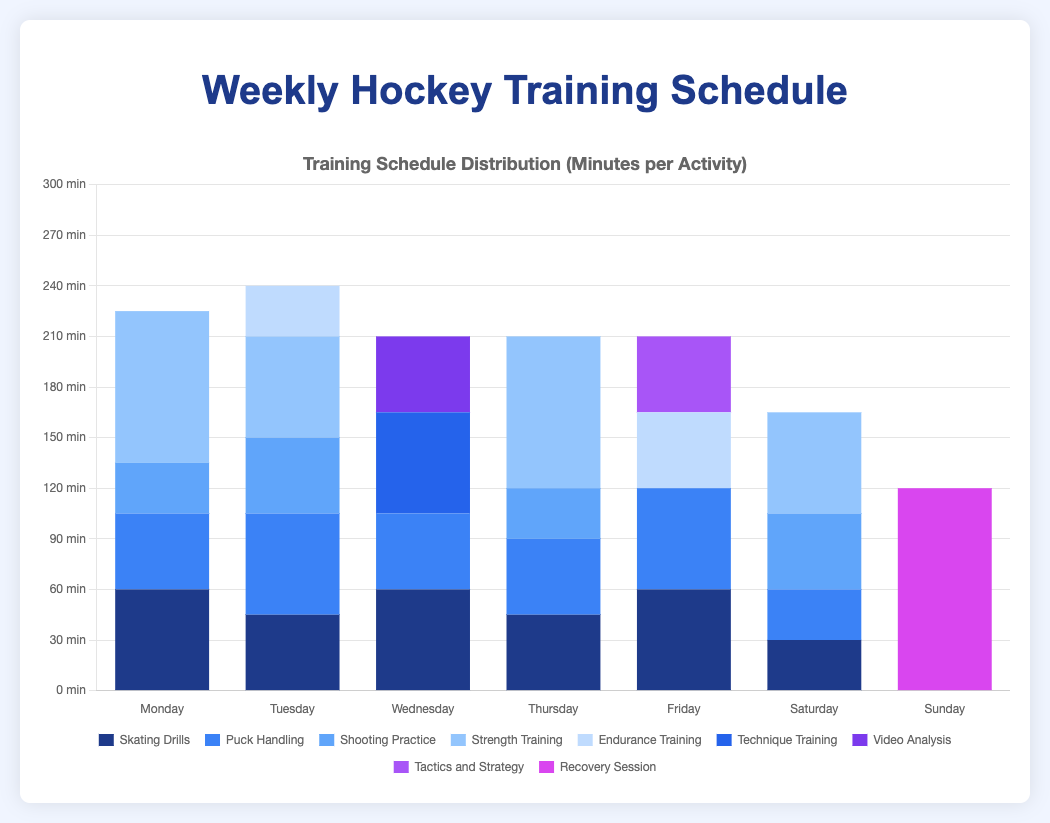What is the total duration of Skating Drills throughout the week? To find the total duration of Skating Drills, sum the duration for each day: 60 (Monday) + 45 (Tuesday) + 60 (Wednesday) + 45 (Thursday) + 60 (Friday) + 30 (Saturday) = 300 minutes.
Answer: 300 minutes On which day is Puck Handling practiced the most, and how long is it practiced? Compare the duration of Puck Handling on each day it appears: 45 (Monday), 60 (Tuesday), 45 (Wednesday), 45 (Thursday), 60 (Friday), 30 (Saturday). The days with the highest duration are Tuesday and Friday, each with 60 minutes.
Answer: Tuesday and Friday, 60 minutes What is the total training time on Wednesday? Sum the duration of all activities on Wednesday: 60 (Skating Drills) + 45 (Puck Handling) + 60 (Technique Training) + 45 (Video Analysis) = 210 minutes.
Answer: 210 minutes Which activity has the longest duration during the entire week and on which day does it occur? Identify the highest single training duration in the dataset. Recovery Session on Sunday has the longest duration of 120 minutes.
Answer: Recovery Session, Sunday What is the average duration of Strength Training across the days it is practiced? First, sum the durations of Strength Training: 90 (Monday) + 60 (Tuesday) + 90 (Thursday) + 60 (Saturday) = 300 minutes. Then, divide by the number of days it is practiced (4 days). The average is 300 / 4 = 75 minutes.
Answer: 75 minutes Compare the total training durations of Tuesday and Thursday. Which day has more total training time? Sum the durations for Tuesday: 45 (Skating Drills) + 60 (Puck Handling) + 45 (Shooting Practice) + 60 (Strength Training) + 30 (Endurance Training) = 240 minutes. For Thursday: 45 (Skating Drills) + 45 (Puck Handling) + 30 (Shooting Practice) + 90 (Strength Training) = 210 minutes. Tuesday has more total training time.
Answer: Tuesday What is the difference in total training duration between Monday and Friday? Sum the durations for Monday: 60 (Skating Drills) + 45 (Puck Handling) + 30 (Shooting Practice) + 90 (Strength Training) = 225 minutes. For Friday: 60 (Skating Drills) + 60 (Puck Handling) + 45 (Endurance Training) + 45 (Tactics and Strategy) = 210 minutes. The difference is 225 - 210 = 15 minutes.
Answer: 15 minutes Which day has the least amount of training activities and what is the total duration for that day? Compare the number of activities per day and their durations. Sunday has only one activity (Recovery Session) with a total duration of 120 minutes.
Answer: Sunday, 120 minutes 